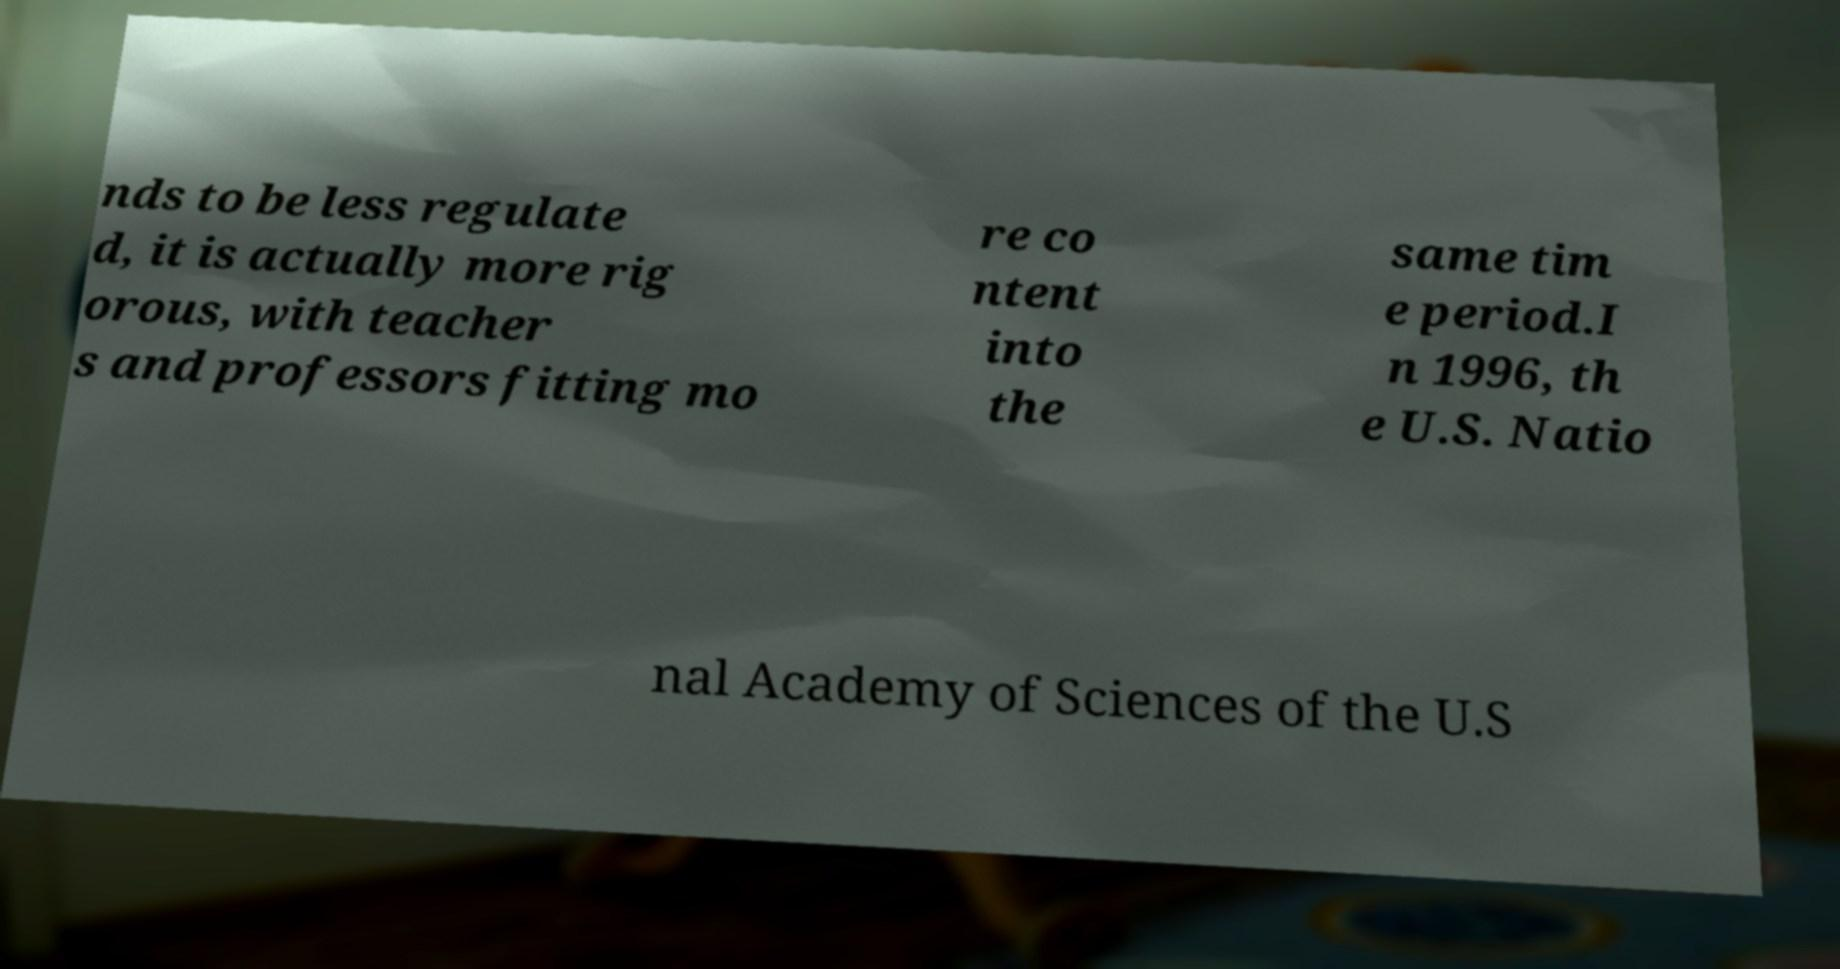Can you accurately transcribe the text from the provided image for me? nds to be less regulate d, it is actually more rig orous, with teacher s and professors fitting mo re co ntent into the same tim e period.I n 1996, th e U.S. Natio nal Academy of Sciences of the U.S 